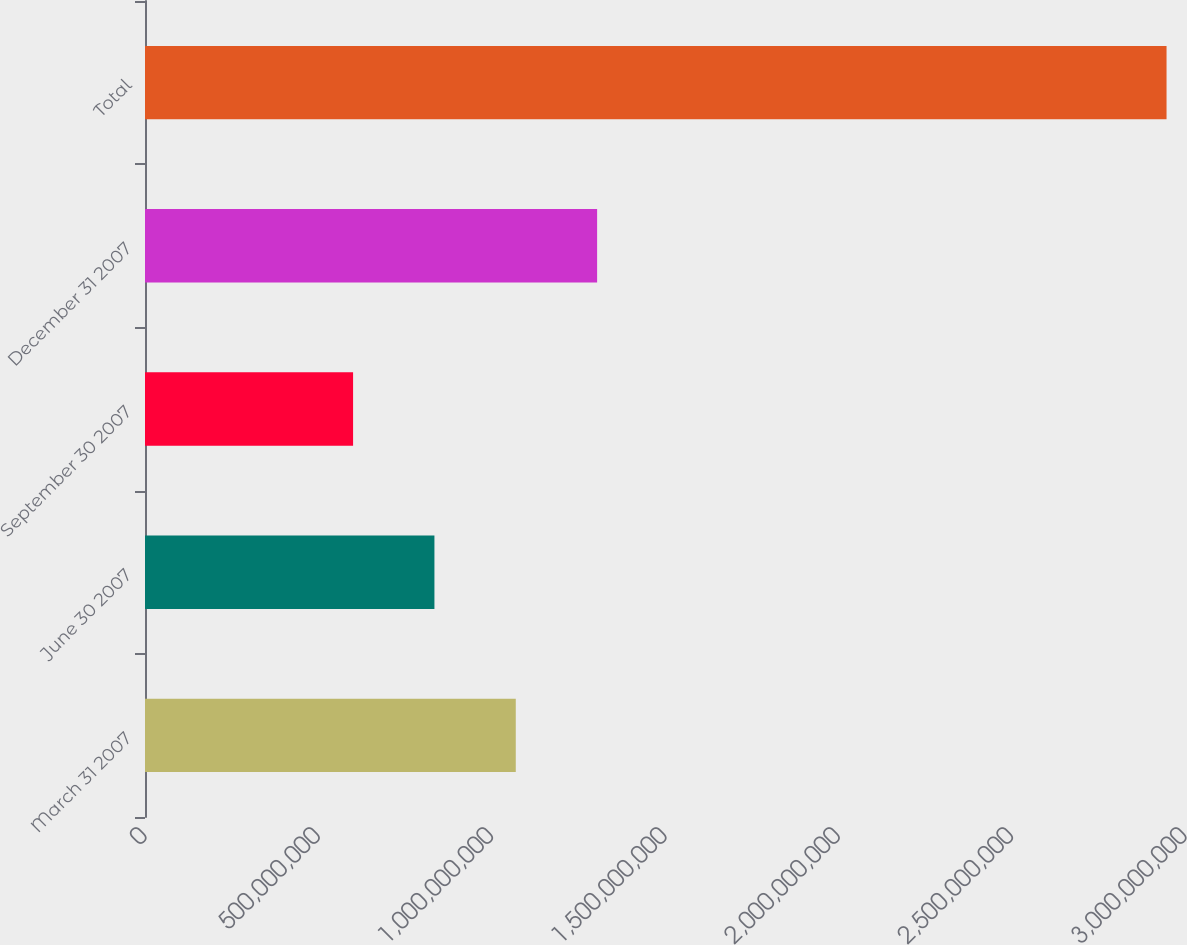<chart> <loc_0><loc_0><loc_500><loc_500><bar_chart><fcel>March 31 2007<fcel>June 30 2007<fcel>September 30 2007<fcel>December 31 2007<fcel>Total<nl><fcel>1.06954e+09<fcel>8.34886e+08<fcel>6.00233e+08<fcel>1.30419e+09<fcel>2.94676e+09<nl></chart> 